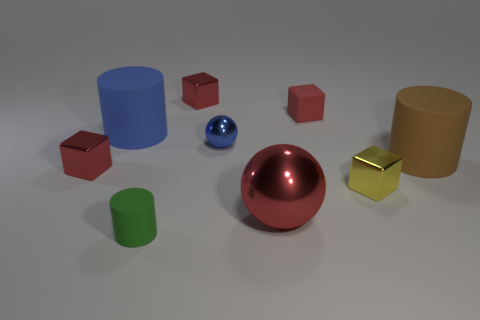How many things are the same color as the small metallic ball?
Provide a short and direct response. 1. The yellow cube is what size?
Give a very brief answer. Small. Does the blue sphere have the same size as the red ball?
Your answer should be very brief. No. There is a metallic cube that is on the right side of the green thing and behind the small yellow metallic thing; what is its color?
Provide a short and direct response. Red. How many tiny red things have the same material as the small blue object?
Provide a succinct answer. 2. What number of tiny red metallic things are there?
Give a very brief answer. 2. Does the brown rubber cylinder have the same size as the cube that is on the left side of the green rubber object?
Offer a very short reply. No. The green cylinder in front of the metal object on the left side of the green rubber thing is made of what material?
Provide a short and direct response. Rubber. What size is the red shiny object behind the metal thing that is left of the matte cylinder in front of the big brown cylinder?
Provide a succinct answer. Small. There is a tiny green matte object; is it the same shape as the small matte object that is behind the green rubber object?
Your answer should be very brief. No. 